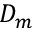Convert formula to latex. <formula><loc_0><loc_0><loc_500><loc_500>D _ { m }</formula> 